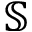Convert formula to latex. <formula><loc_0><loc_0><loc_500><loc_500>{ \mathbb { S } }</formula> 